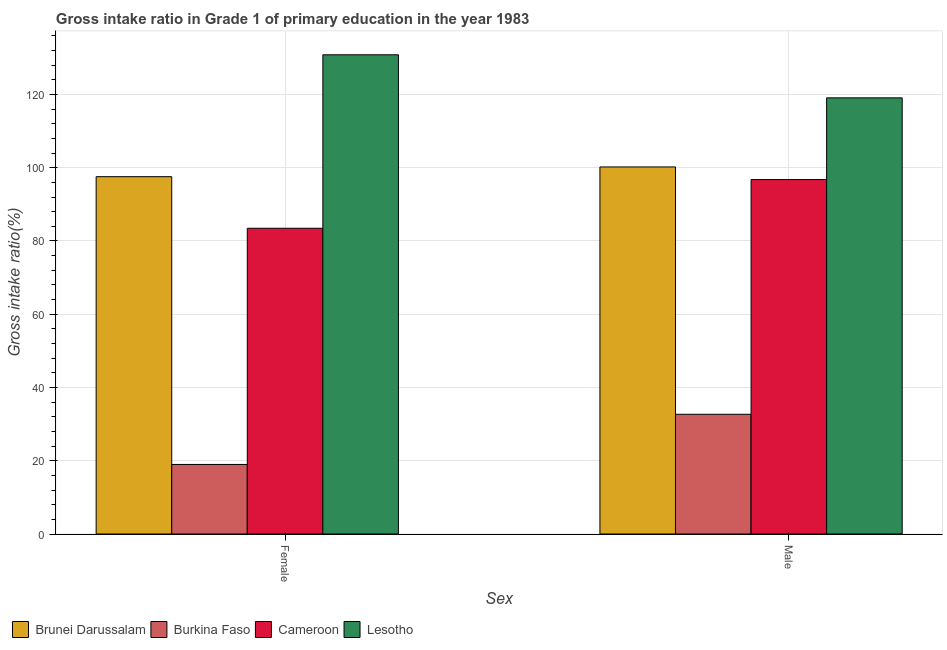How many groups of bars are there?
Provide a short and direct response. 2. Are the number of bars per tick equal to the number of legend labels?
Keep it short and to the point. Yes. How many bars are there on the 2nd tick from the right?
Provide a short and direct response. 4. What is the gross intake ratio(male) in Cameroon?
Keep it short and to the point. 96.76. Across all countries, what is the maximum gross intake ratio(female)?
Make the answer very short. 130.83. Across all countries, what is the minimum gross intake ratio(male)?
Your answer should be compact. 32.68. In which country was the gross intake ratio(male) maximum?
Offer a terse response. Lesotho. In which country was the gross intake ratio(female) minimum?
Your answer should be compact. Burkina Faso. What is the total gross intake ratio(male) in the graph?
Keep it short and to the point. 348.72. What is the difference between the gross intake ratio(male) in Lesotho and that in Brunei Darussalam?
Make the answer very short. 18.86. What is the difference between the gross intake ratio(male) in Burkina Faso and the gross intake ratio(female) in Brunei Darussalam?
Your answer should be compact. -64.87. What is the average gross intake ratio(female) per country?
Make the answer very short. 82.71. What is the difference between the gross intake ratio(female) and gross intake ratio(male) in Cameroon?
Give a very brief answer. -13.29. In how many countries, is the gross intake ratio(male) greater than 84 %?
Provide a succinct answer. 3. What is the ratio of the gross intake ratio(male) in Brunei Darussalam to that in Cameroon?
Your response must be concise. 1.04. Is the gross intake ratio(female) in Burkina Faso less than that in Lesotho?
Offer a terse response. Yes. In how many countries, is the gross intake ratio(female) greater than the average gross intake ratio(female) taken over all countries?
Keep it short and to the point. 3. What does the 1st bar from the left in Female represents?
Ensure brevity in your answer.  Brunei Darussalam. What does the 3rd bar from the right in Male represents?
Your answer should be very brief. Burkina Faso. How many countries are there in the graph?
Ensure brevity in your answer.  4. What is the difference between two consecutive major ticks on the Y-axis?
Your answer should be very brief. 20. Does the graph contain any zero values?
Your answer should be very brief. No. Does the graph contain grids?
Ensure brevity in your answer.  Yes. How are the legend labels stacked?
Give a very brief answer. Horizontal. What is the title of the graph?
Your response must be concise. Gross intake ratio in Grade 1 of primary education in the year 1983. Does "Korea (Democratic)" appear as one of the legend labels in the graph?
Provide a succinct answer. No. What is the label or title of the X-axis?
Your response must be concise. Sex. What is the label or title of the Y-axis?
Ensure brevity in your answer.  Gross intake ratio(%). What is the Gross intake ratio(%) of Brunei Darussalam in Female?
Offer a very short reply. 97.55. What is the Gross intake ratio(%) in Burkina Faso in Female?
Ensure brevity in your answer.  18.98. What is the Gross intake ratio(%) in Cameroon in Female?
Ensure brevity in your answer.  83.47. What is the Gross intake ratio(%) of Lesotho in Female?
Provide a succinct answer. 130.83. What is the Gross intake ratio(%) in Brunei Darussalam in Male?
Give a very brief answer. 100.21. What is the Gross intake ratio(%) of Burkina Faso in Male?
Give a very brief answer. 32.68. What is the Gross intake ratio(%) in Cameroon in Male?
Your response must be concise. 96.76. What is the Gross intake ratio(%) in Lesotho in Male?
Make the answer very short. 119.07. Across all Sex, what is the maximum Gross intake ratio(%) in Brunei Darussalam?
Keep it short and to the point. 100.21. Across all Sex, what is the maximum Gross intake ratio(%) in Burkina Faso?
Offer a terse response. 32.68. Across all Sex, what is the maximum Gross intake ratio(%) in Cameroon?
Offer a terse response. 96.76. Across all Sex, what is the maximum Gross intake ratio(%) in Lesotho?
Make the answer very short. 130.83. Across all Sex, what is the minimum Gross intake ratio(%) of Brunei Darussalam?
Offer a terse response. 97.55. Across all Sex, what is the minimum Gross intake ratio(%) of Burkina Faso?
Your answer should be very brief. 18.98. Across all Sex, what is the minimum Gross intake ratio(%) in Cameroon?
Offer a terse response. 83.47. Across all Sex, what is the minimum Gross intake ratio(%) in Lesotho?
Ensure brevity in your answer.  119.07. What is the total Gross intake ratio(%) of Brunei Darussalam in the graph?
Provide a succinct answer. 197.76. What is the total Gross intake ratio(%) in Burkina Faso in the graph?
Your answer should be very brief. 51.67. What is the total Gross intake ratio(%) of Cameroon in the graph?
Make the answer very short. 180.23. What is the total Gross intake ratio(%) of Lesotho in the graph?
Offer a terse response. 249.9. What is the difference between the Gross intake ratio(%) of Brunei Darussalam in Female and that in Male?
Offer a terse response. -2.66. What is the difference between the Gross intake ratio(%) in Burkina Faso in Female and that in Male?
Your answer should be very brief. -13.7. What is the difference between the Gross intake ratio(%) in Cameroon in Female and that in Male?
Make the answer very short. -13.29. What is the difference between the Gross intake ratio(%) of Lesotho in Female and that in Male?
Provide a short and direct response. 11.76. What is the difference between the Gross intake ratio(%) in Brunei Darussalam in Female and the Gross intake ratio(%) in Burkina Faso in Male?
Offer a very short reply. 64.87. What is the difference between the Gross intake ratio(%) in Brunei Darussalam in Female and the Gross intake ratio(%) in Cameroon in Male?
Give a very brief answer. 0.79. What is the difference between the Gross intake ratio(%) of Brunei Darussalam in Female and the Gross intake ratio(%) of Lesotho in Male?
Your answer should be very brief. -21.52. What is the difference between the Gross intake ratio(%) of Burkina Faso in Female and the Gross intake ratio(%) of Cameroon in Male?
Ensure brevity in your answer.  -77.78. What is the difference between the Gross intake ratio(%) of Burkina Faso in Female and the Gross intake ratio(%) of Lesotho in Male?
Offer a terse response. -100.09. What is the difference between the Gross intake ratio(%) in Cameroon in Female and the Gross intake ratio(%) in Lesotho in Male?
Make the answer very short. -35.6. What is the average Gross intake ratio(%) of Brunei Darussalam per Sex?
Your answer should be very brief. 98.88. What is the average Gross intake ratio(%) of Burkina Faso per Sex?
Your response must be concise. 25.83. What is the average Gross intake ratio(%) of Cameroon per Sex?
Your response must be concise. 90.12. What is the average Gross intake ratio(%) of Lesotho per Sex?
Keep it short and to the point. 124.95. What is the difference between the Gross intake ratio(%) of Brunei Darussalam and Gross intake ratio(%) of Burkina Faso in Female?
Ensure brevity in your answer.  78.57. What is the difference between the Gross intake ratio(%) of Brunei Darussalam and Gross intake ratio(%) of Cameroon in Female?
Provide a succinct answer. 14.08. What is the difference between the Gross intake ratio(%) of Brunei Darussalam and Gross intake ratio(%) of Lesotho in Female?
Offer a terse response. -33.28. What is the difference between the Gross intake ratio(%) in Burkina Faso and Gross intake ratio(%) in Cameroon in Female?
Your response must be concise. -64.48. What is the difference between the Gross intake ratio(%) of Burkina Faso and Gross intake ratio(%) of Lesotho in Female?
Keep it short and to the point. -111.84. What is the difference between the Gross intake ratio(%) of Cameroon and Gross intake ratio(%) of Lesotho in Female?
Make the answer very short. -47.36. What is the difference between the Gross intake ratio(%) in Brunei Darussalam and Gross intake ratio(%) in Burkina Faso in Male?
Your answer should be very brief. 67.52. What is the difference between the Gross intake ratio(%) in Brunei Darussalam and Gross intake ratio(%) in Cameroon in Male?
Your answer should be compact. 3.45. What is the difference between the Gross intake ratio(%) in Brunei Darussalam and Gross intake ratio(%) in Lesotho in Male?
Your answer should be compact. -18.86. What is the difference between the Gross intake ratio(%) in Burkina Faso and Gross intake ratio(%) in Cameroon in Male?
Make the answer very short. -64.08. What is the difference between the Gross intake ratio(%) in Burkina Faso and Gross intake ratio(%) in Lesotho in Male?
Your response must be concise. -86.39. What is the difference between the Gross intake ratio(%) in Cameroon and Gross intake ratio(%) in Lesotho in Male?
Provide a succinct answer. -22.31. What is the ratio of the Gross intake ratio(%) in Brunei Darussalam in Female to that in Male?
Give a very brief answer. 0.97. What is the ratio of the Gross intake ratio(%) of Burkina Faso in Female to that in Male?
Your answer should be compact. 0.58. What is the ratio of the Gross intake ratio(%) in Cameroon in Female to that in Male?
Provide a short and direct response. 0.86. What is the ratio of the Gross intake ratio(%) of Lesotho in Female to that in Male?
Give a very brief answer. 1.1. What is the difference between the highest and the second highest Gross intake ratio(%) of Brunei Darussalam?
Your answer should be very brief. 2.66. What is the difference between the highest and the second highest Gross intake ratio(%) of Burkina Faso?
Ensure brevity in your answer.  13.7. What is the difference between the highest and the second highest Gross intake ratio(%) of Cameroon?
Offer a very short reply. 13.29. What is the difference between the highest and the second highest Gross intake ratio(%) in Lesotho?
Keep it short and to the point. 11.76. What is the difference between the highest and the lowest Gross intake ratio(%) in Brunei Darussalam?
Keep it short and to the point. 2.66. What is the difference between the highest and the lowest Gross intake ratio(%) of Burkina Faso?
Keep it short and to the point. 13.7. What is the difference between the highest and the lowest Gross intake ratio(%) in Cameroon?
Your response must be concise. 13.29. What is the difference between the highest and the lowest Gross intake ratio(%) of Lesotho?
Provide a short and direct response. 11.76. 